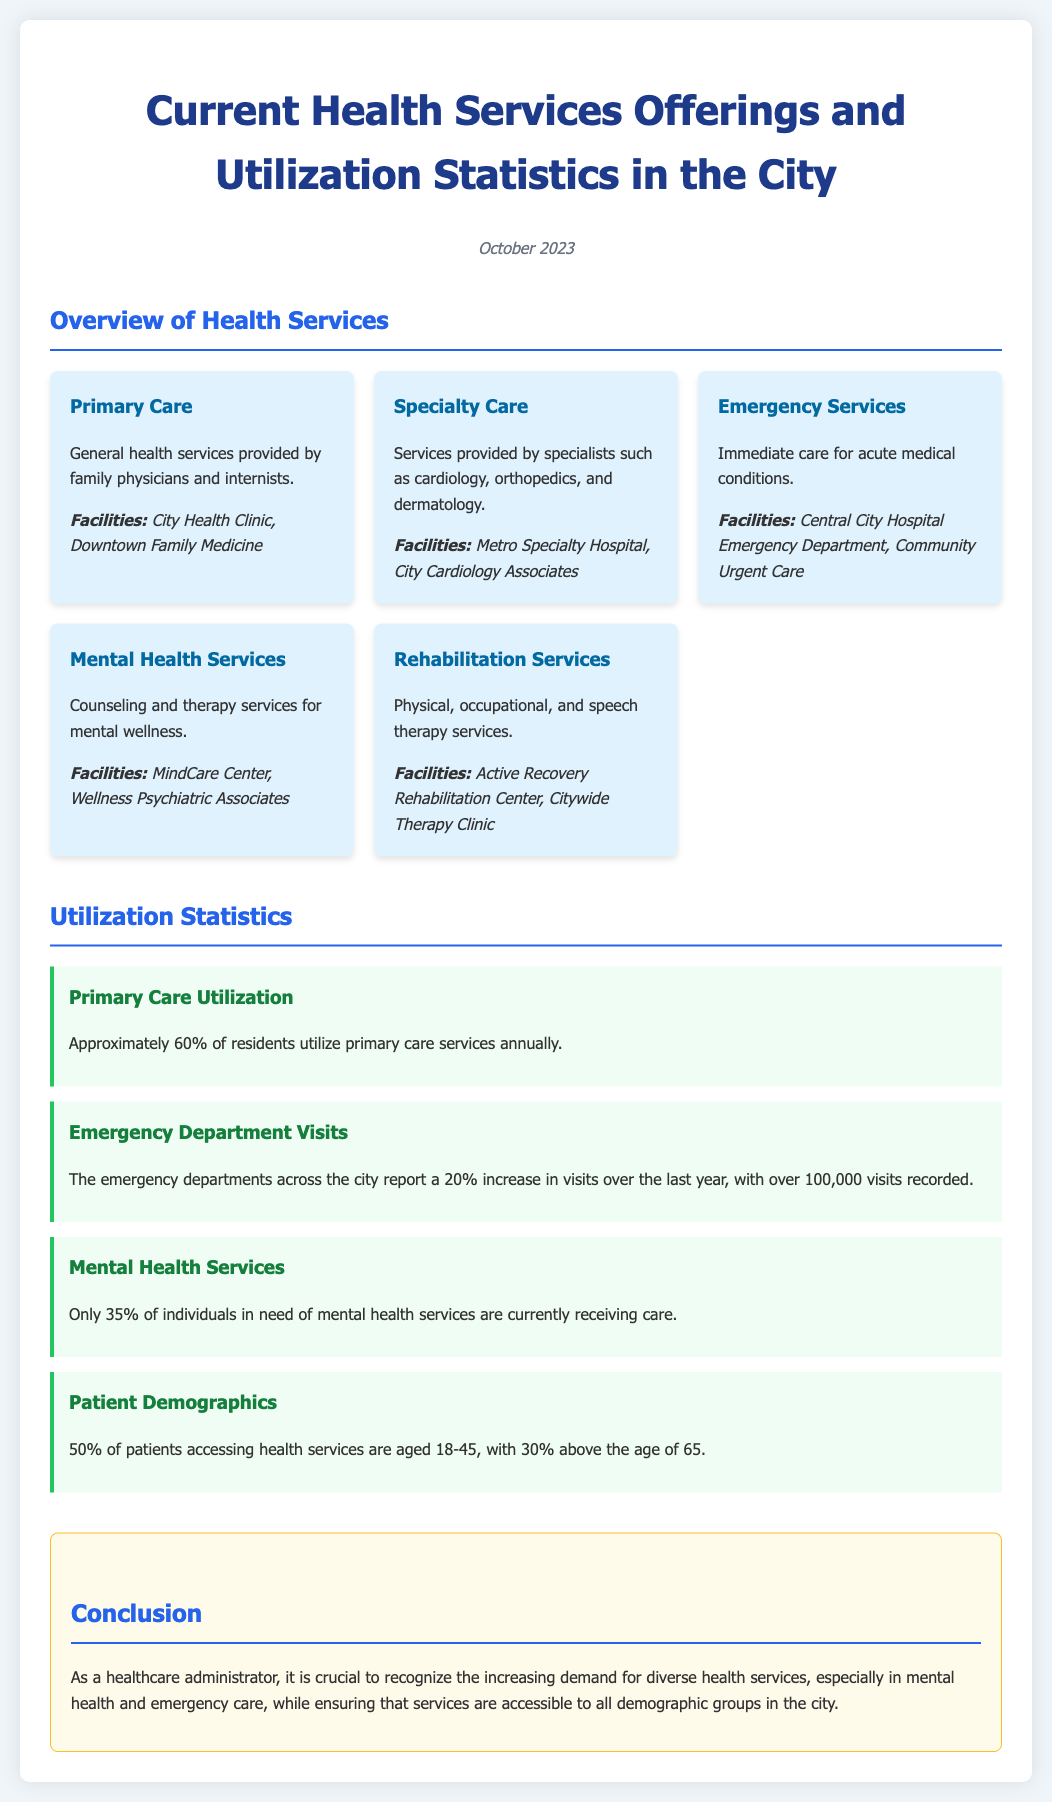What are the primary care facilities? The document lists City Health Clinic and Downtown Family Medicine as primary care facilities.
Answer: City Health Clinic, Downtown Family Medicine What percentage of residents utilize primary care services? The document states that approximately 60% of residents use primary care services annually.
Answer: 60% How many emergency department visits were recorded? The document mentions over 100,000 visits recorded in the emergency departments across the city.
Answer: Over 100,000 What is the reported increase in emergency department visits? The document reports a 20% increase in visits over the last year.
Answer: 20% What percentage of individuals in need of mental health services are receiving care? According to the document, only 35% of individuals in need of mental health services are currently receiving care.
Answer: 35% What age group comprises 50% of patients accessing health services? The document indicates that 50% of patients accessing health services are aged 18-45.
Answer: 18-45 Which types of services are included in rehabilitation services? The document specifies physical, occupational, and speech therapy services as part of rehabilitation services.
Answer: Physical, occupational, and speech therapy What is the overall conclusion regarding health services demand? The document concludes that there is an increasing demand for diverse health services, especially in mental health and emergency care.
Answer: Increasing demand for diverse health services What is the focus of the document? The focus of the document is on current health services offerings and utilization statistics in the city.
Answer: Current health services offerings and utilization statistics 